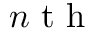<formula> <loc_0><loc_0><loc_500><loc_500>n t h</formula> 